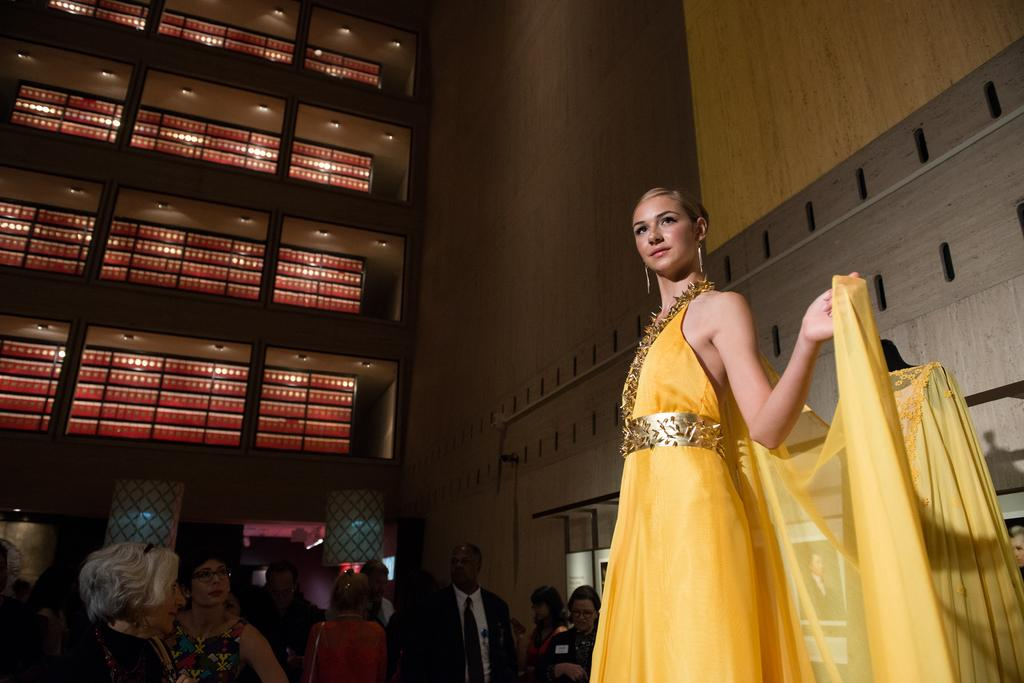Who is the main subject in the image? There is a woman in the image. What is the woman doing in the image? The woman is standing and smiling. Who else is present in the image? There is a group of people in front of the woman. What can be seen in the background of the image? There is a wall and lights in the background of the image. What type of crush can be seen in the image? There is no crush present in the image; it features a woman standing and smiling with a group of people in front of her. 